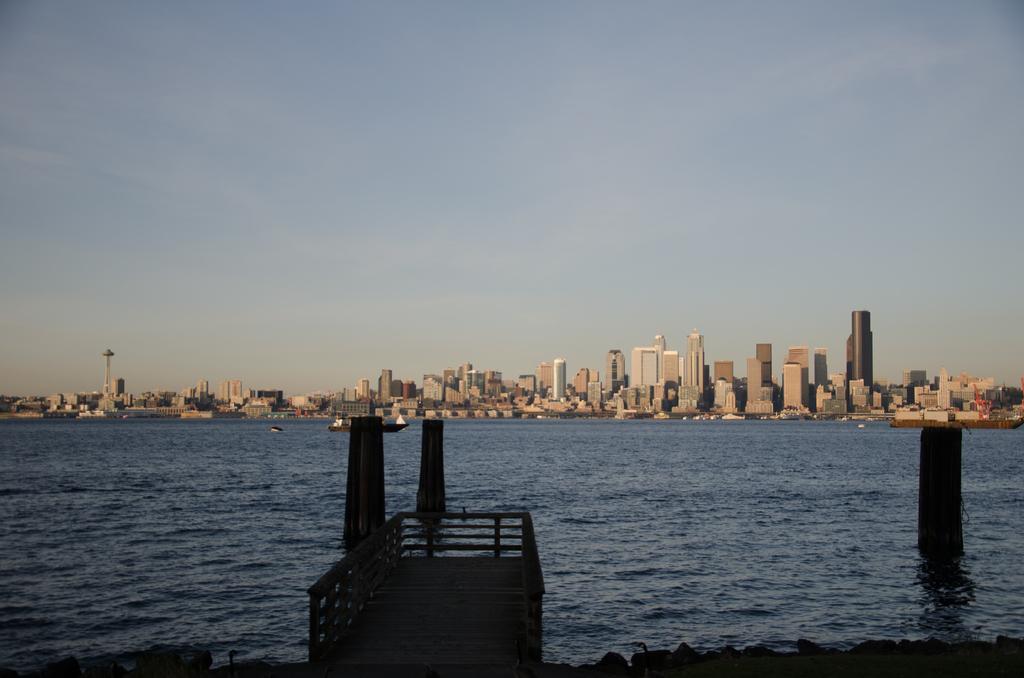How would you summarize this image in a sentence or two? In this image there is a bridge in the water. In the middle there is a boat in the water. In the background there are so many tall buildings one beside the other. At the top there is the sky. 